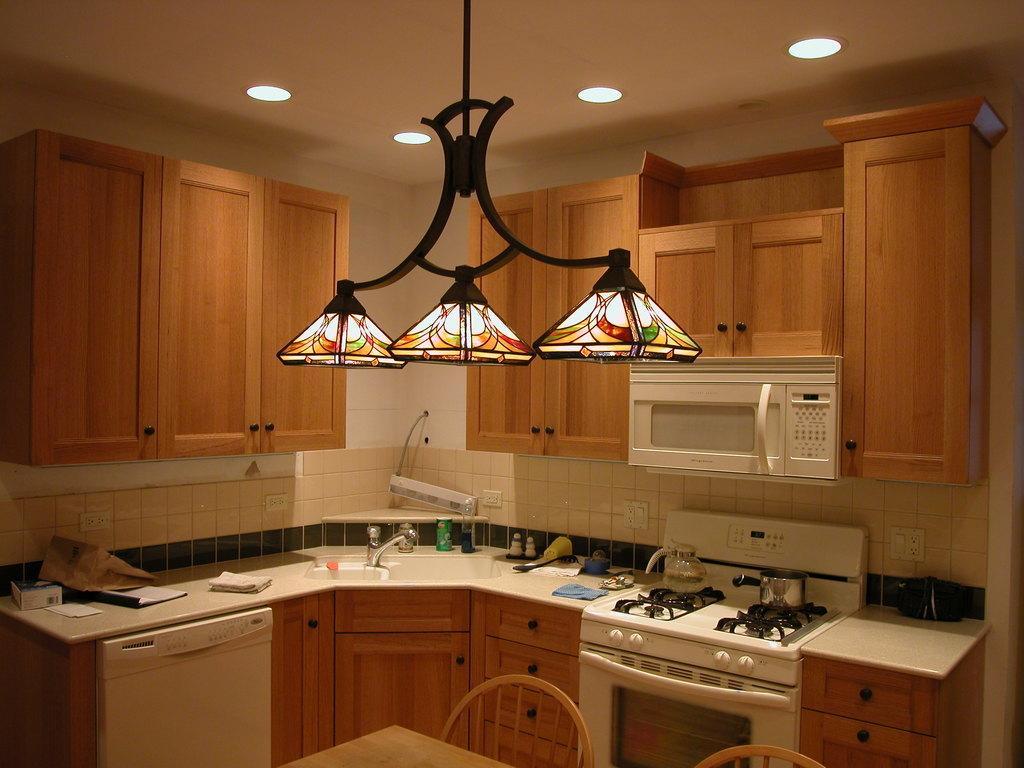Describe this image in one or two sentences. In the picture we can see a kitchen room in it, we can see a desk with four stoves and a pressure cooker on it and besides, we can see some things like glasses are kept and under the desk, we can see wooden cupboards and to the wall we can see some cupboards and we can also see a micro oven which is white in color and to the ceiling we can see the lights. 